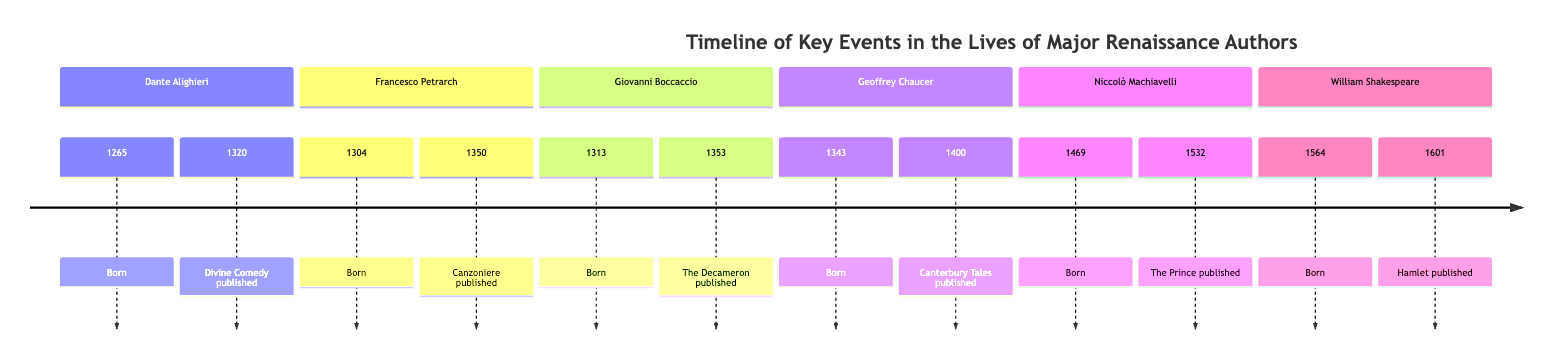What year was Dante Alighieri born? The diagram shows the section for Dante Alighieri, where the event indicates "Born" and lists the year 1265 next to it. Therefore, the answer is taken directly from this part of the diagram.
Answer: 1265 Which author published The Prince? According to the diagram, the section for Niccolò Machiavelli includes the publication of "The Prince" in 1532. This direct reference allows us to identify that it is Machiavelli who published this work.
Answer: Niccolò Machiavelli How many authors are listed in the diagram? By examining all sections in the timeline, one can count the distinct authors provided: Dante Alighieri, Francesco Petrarch, Giovanni Boccaccio, Geoffrey Chaucer, Niccolò Machiavelli, and William Shakespeare. This totals up to six authors.
Answer: 6 Which work was published first among the authors listed? The diagram helps compare publication years. The earliest publication is Dante Alighieri's "Divine Comedy" in 1320, and no other work is shown to be published before this year, making it the first among the listed works.
Answer: Divine Comedy What year did William Shakespeare's Hamlet get published? The timeline directly indicates that Hamlet was published in the year 1601, which is stated next to the section for William Shakespeare in the diagram.
Answer: 1601 Which two authors were born in the 1300s? By looking at the birth years of the authors, Dante Alighieri (1265) and Francesco Petrarch (1304) were born before the 1300s, while Giovanni Boccaccio (1313) was born in the 1300s. The other three authors are from the 1400s and 1500s, making Boccaccio and Petrarch are the only ones in the given timeframe.
Answer: Francesco Petrarch, Giovanni Boccaccio What is the publication year of The Decameron? In the timeline, under Giovanni Boccaccio's section, it shows that "The Decameron" was published in 1353, which directly answers the question by referencing the work and its respective year in the diagram.
Answer: 1353 